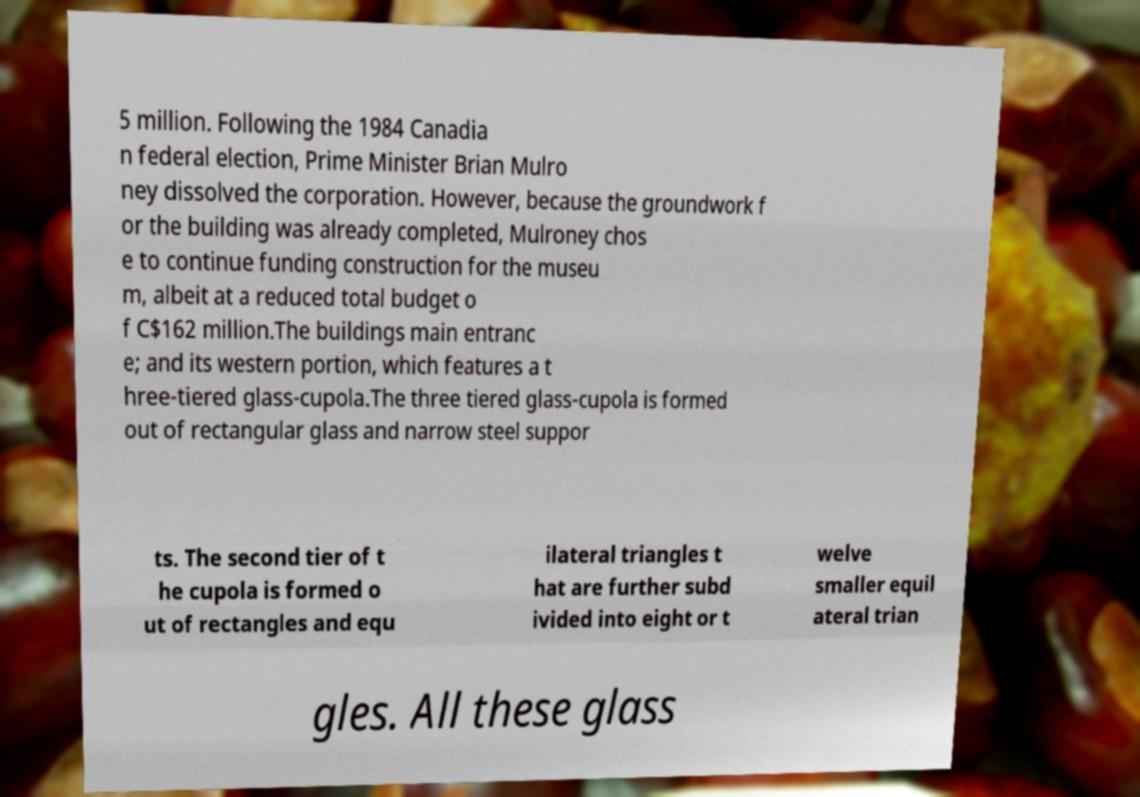Could you extract and type out the text from this image? 5 million. Following the 1984 Canadia n federal election, Prime Minister Brian Mulro ney dissolved the corporation. However, because the groundwork f or the building was already completed, Mulroney chos e to continue funding construction for the museu m, albeit at a reduced total budget o f C$162 million.The buildings main entranc e; and its western portion, which features a t hree-tiered glass-cupola.The three tiered glass-cupola is formed out of rectangular glass and narrow steel suppor ts. The second tier of t he cupola is formed o ut of rectangles and equ ilateral triangles t hat are further subd ivided into eight or t welve smaller equil ateral trian gles. All these glass 